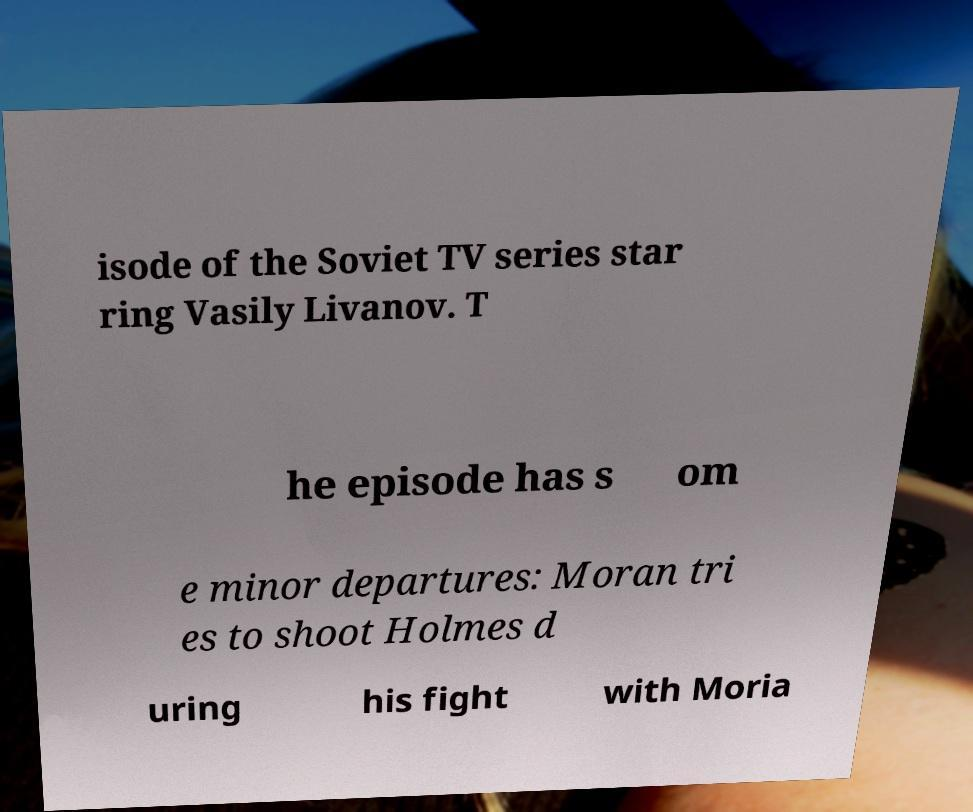Could you assist in decoding the text presented in this image and type it out clearly? isode of the Soviet TV series star ring Vasily Livanov. T he episode has s om e minor departures: Moran tri es to shoot Holmes d uring his fight with Moria 